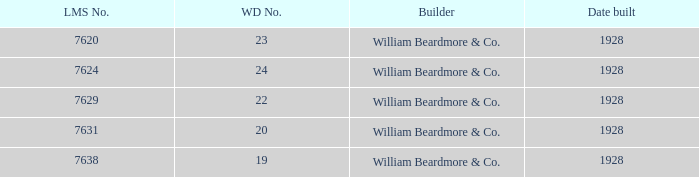Identify the total quantity of serial numbers for 24 wd no. 1.0. 